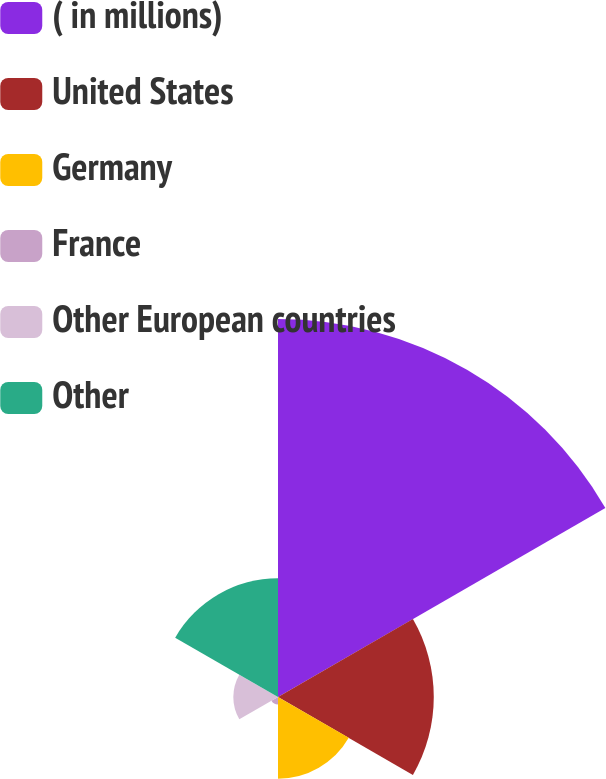Convert chart to OTSL. <chart><loc_0><loc_0><loc_500><loc_500><pie_chart><fcel>( in millions)<fcel>United States<fcel>Germany<fcel>France<fcel>Other European countries<fcel>Other<nl><fcel>48.07%<fcel>19.81%<fcel>10.39%<fcel>0.96%<fcel>5.68%<fcel>15.1%<nl></chart> 